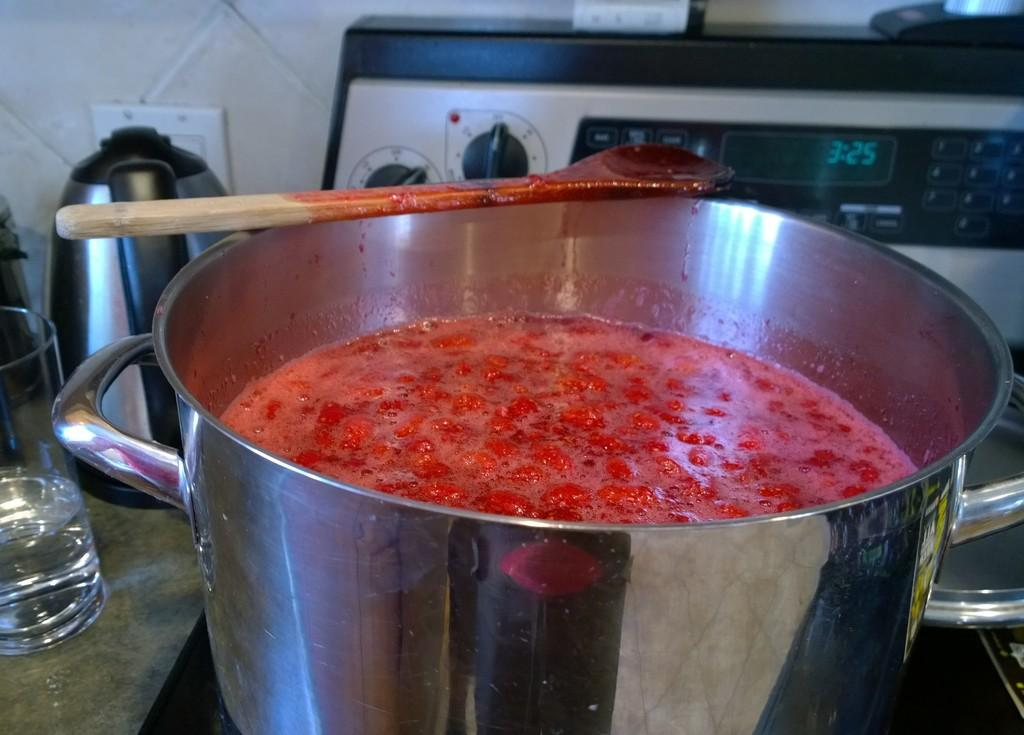What is on the stove in the image? There is a vessel on the stove in the image. What can be seen in the image besides the vessel on the stove? A glass and a water heater are present in the image. What is used for stirring or serving the contents of the vessel? A wooden serving spoon is visible on the vessel. What type of jeans is the person wearing in the image? There is no person present in the image, and therefore no clothing can be observed. 